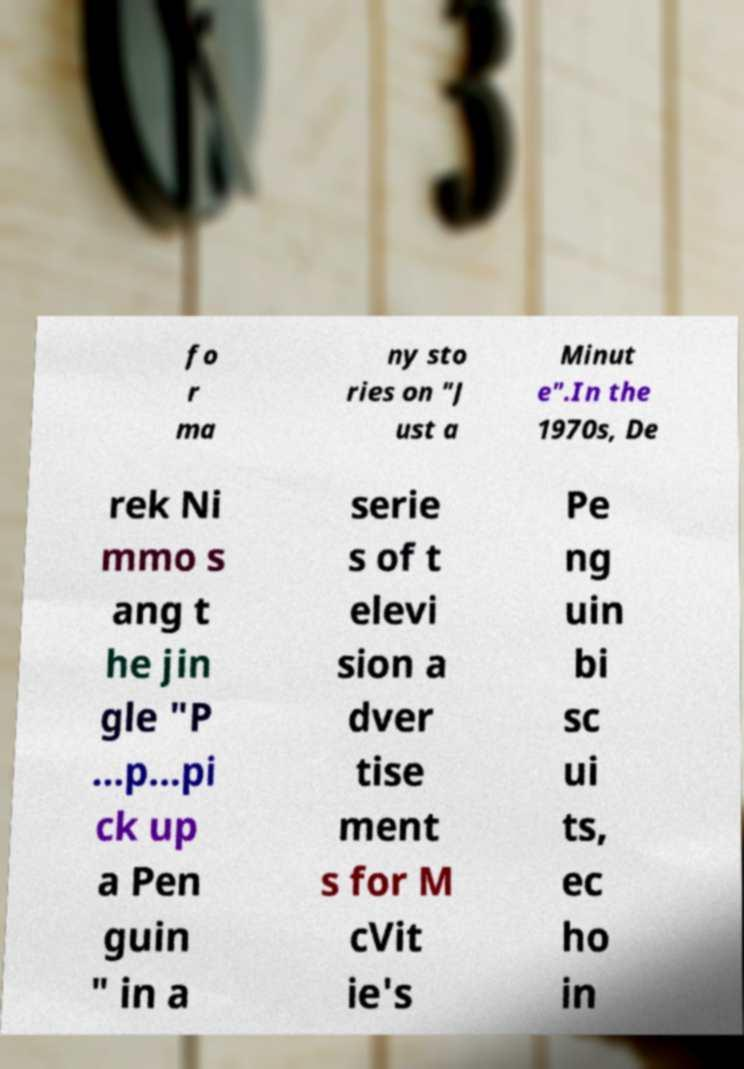Could you assist in decoding the text presented in this image and type it out clearly? fo r ma ny sto ries on "J ust a Minut e".In the 1970s, De rek Ni mmo s ang t he jin gle "P …p…pi ck up a Pen guin " in a serie s of t elevi sion a dver tise ment s for M cVit ie's Pe ng uin bi sc ui ts, ec ho in 